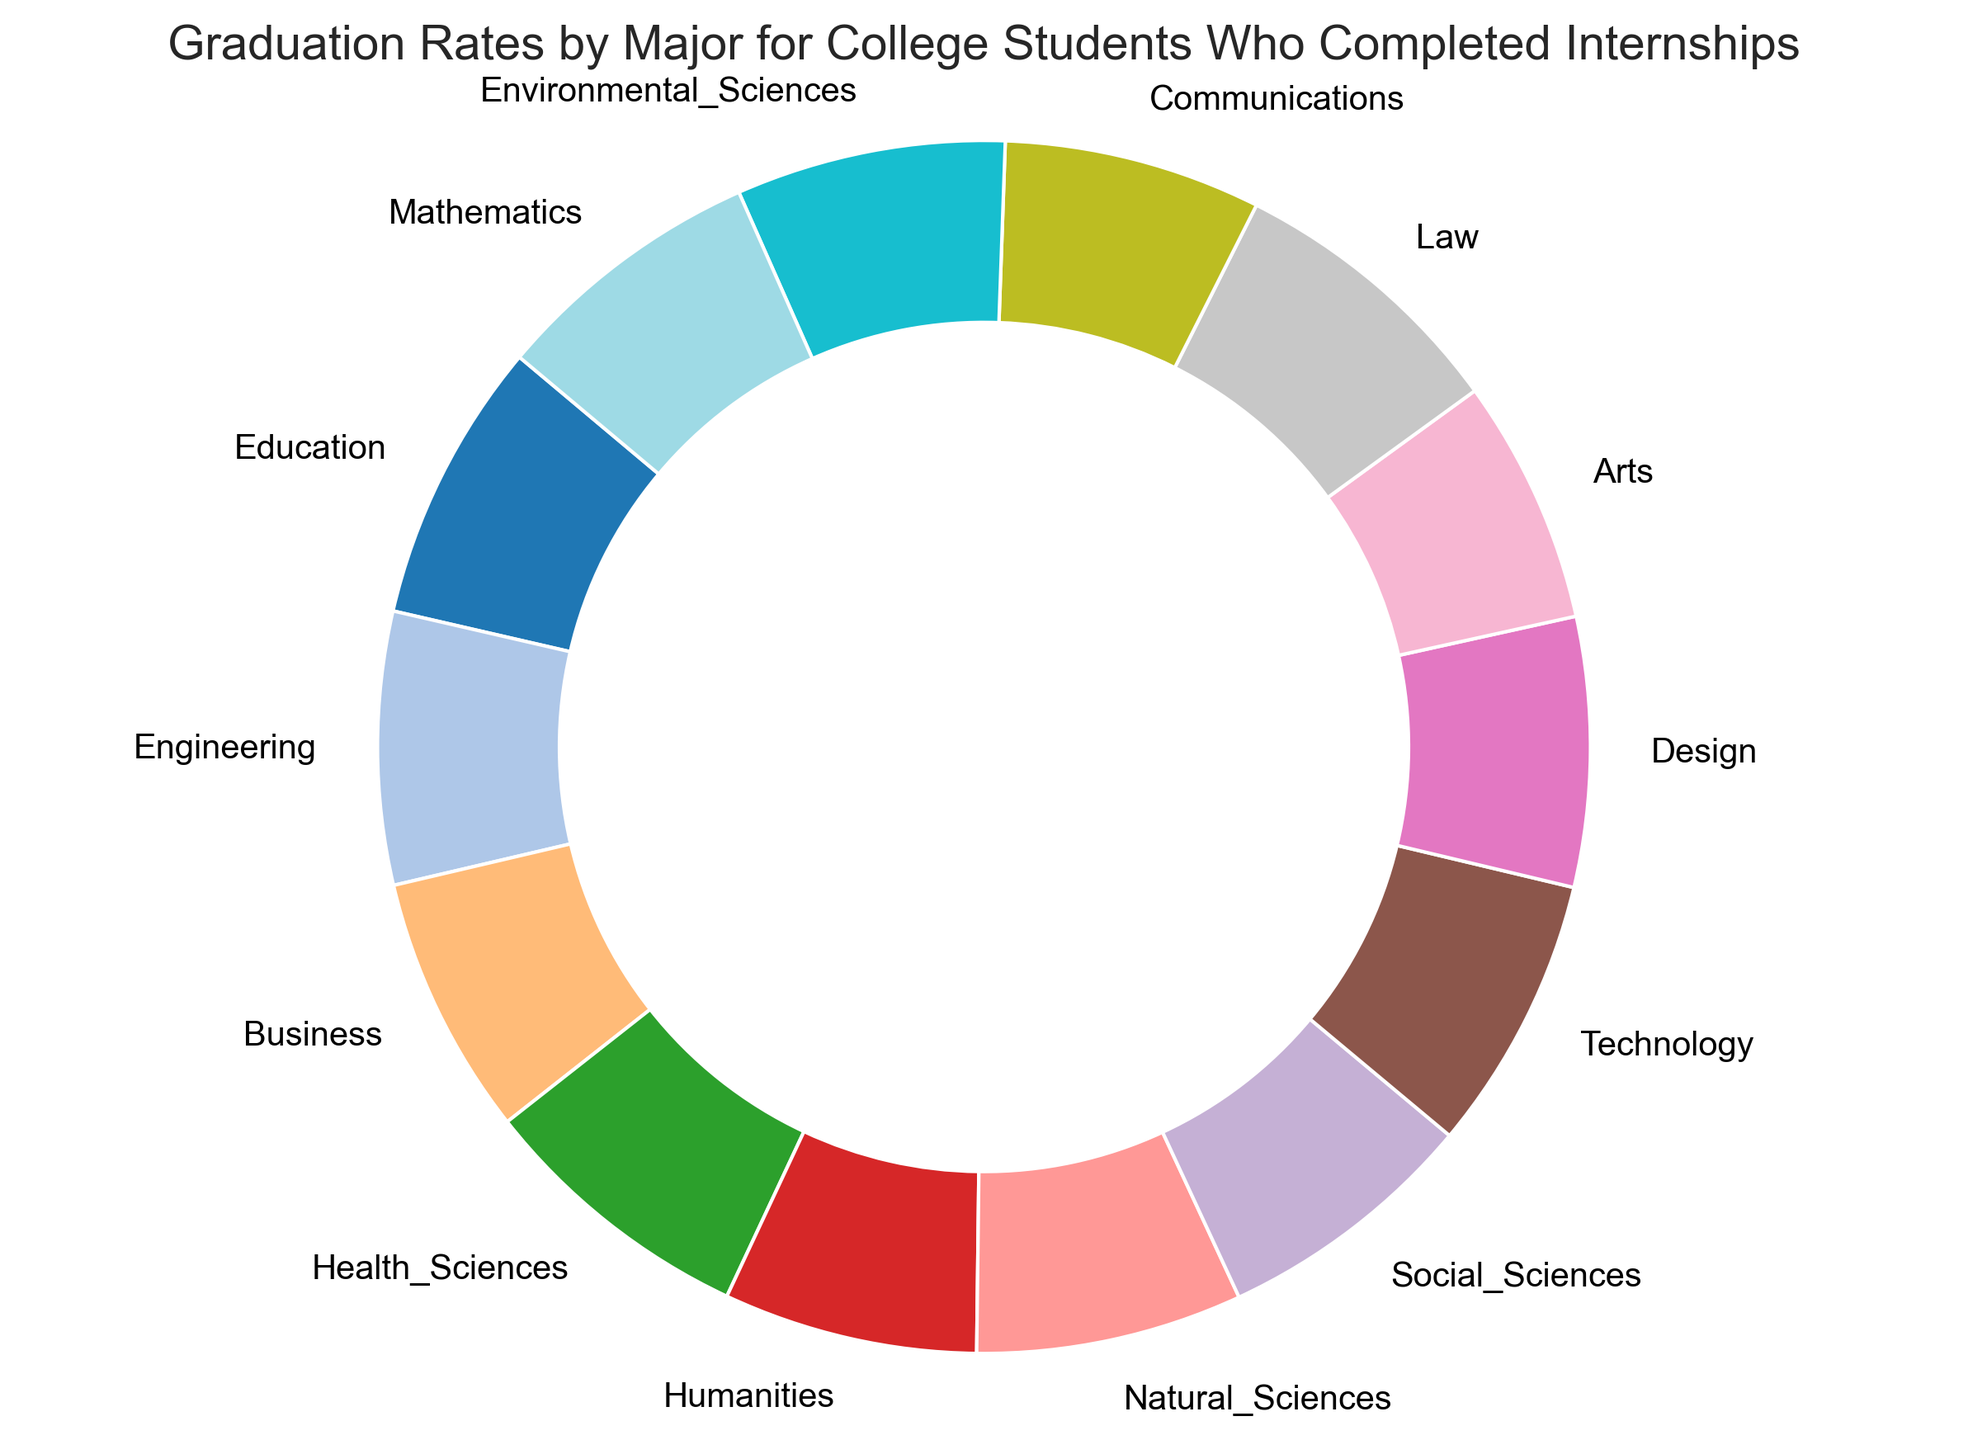Which major has the highest graduation rate? The Law major has the highest graduation rate at 93%, as indicated by the figure.
Answer: Law What is the combined graduation rate for the Engineering and Mathematics majors? The Engineering major has a graduation rate of 89%, and the Mathematics major also has 89%. Their combined rate is 89 + 89 = 178.
Answer: 178 How does the graduation rate for Technology compare to that for Business? The graduation rate for Technology is 90%, whereas for Business, it is 85%. Therefore, the Technology major has a graduation rate that is 5% higher than Business.
Answer: Technology is 5% higher than Business Which major has the lowest graduation rate? The Arts major has the lowest graduation rate at 80%, as indicated by the figure.
Answer: Arts What is the average graduation rate for all the majors depicted? Add up all the graduation rates and divide by the number of majors: (92 + 89 + 85 + 91 + 83 + 87 + 86 + 90 + 88 + 80 + 93 + 84 + 88 + 89) / 14 = 89
Answer: 89 Between Health Sciences and Natural Sciences, which has a higher graduation rate and by how much? Health Sciences have a graduation rate of 91%, and Natural Sciences have 87%. Therefore, Health Sciences is higher by 91 - 87 = 4%.
Answer: Health Sciences by 4% What is the median graduation rate among these majors? When the rates are ordered (80, 83, 84, 85, 86, 87, 88, 88, 89, 89, 90, 91, 92, 93), the median, being the middle value, falls between the 7th and 8th values (88 and 88), making the median rate 88.
Answer: 88 Which major has a graduation rate closest to the overall average? The overall average graduation rate is 89. The majors closest to this are Engineering, Mathematics, both at exactly 89.
Answer: Engineering and Mathematics What is the difference between the highest and the lowest graduation rates? The highest rate is 93% for Law, and the lowest is 80% for Arts. The difference is 93 - 80 = 13%.
Answer: 13% What is the sum of the graduation rates for the majors in the Humanities and Social Sciences categories combined? Humanities have an 83% rate, and Social Sciences have 86%. The sum is 83 + 86 = 169.
Answer: 169 